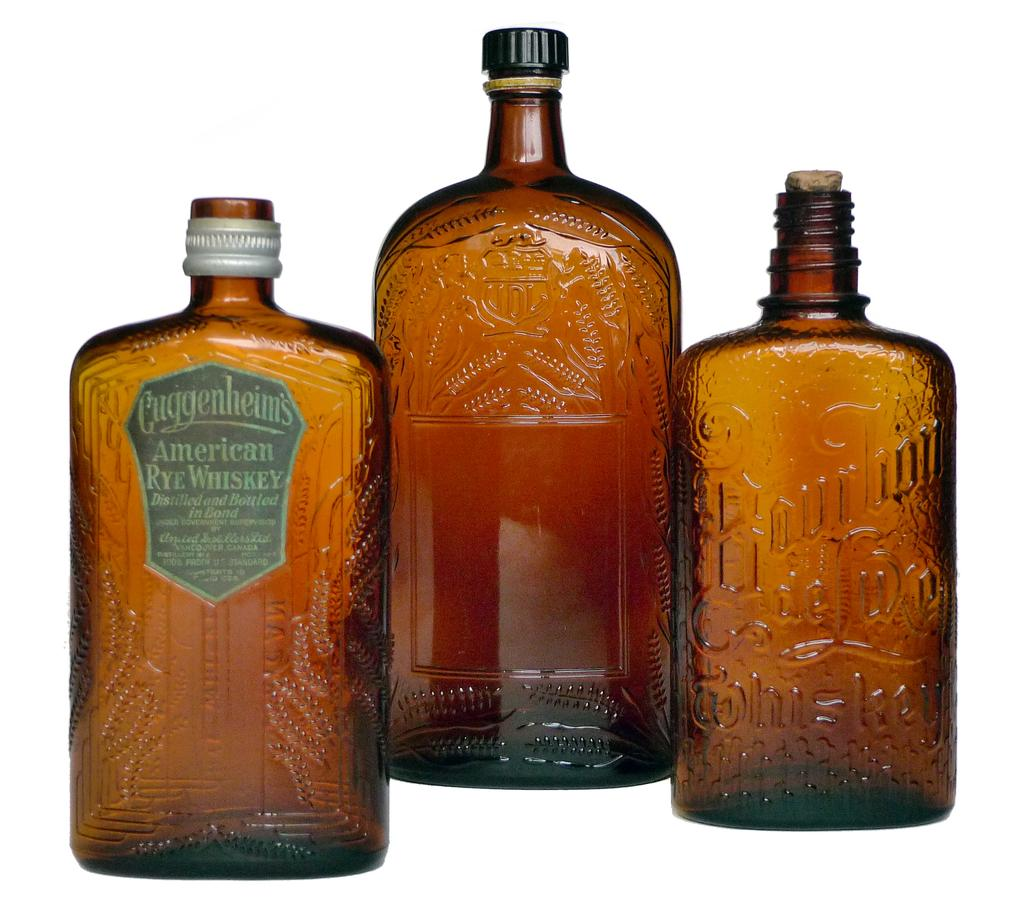<image>
Describe the image concisely. A bottle of Cuggenheims, American Rye Whiskey is next to two other bottles. 